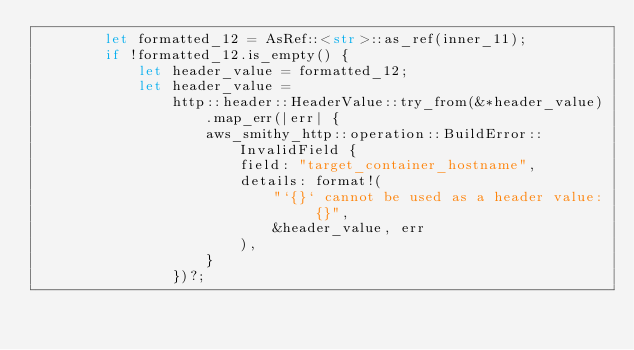<code> <loc_0><loc_0><loc_500><loc_500><_Rust_>        let formatted_12 = AsRef::<str>::as_ref(inner_11);
        if !formatted_12.is_empty() {
            let header_value = formatted_12;
            let header_value =
                http::header::HeaderValue::try_from(&*header_value).map_err(|err| {
                    aws_smithy_http::operation::BuildError::InvalidField {
                        field: "target_container_hostname",
                        details: format!(
                            "`{}` cannot be used as a header value: {}",
                            &header_value, err
                        ),
                    }
                })?;</code> 